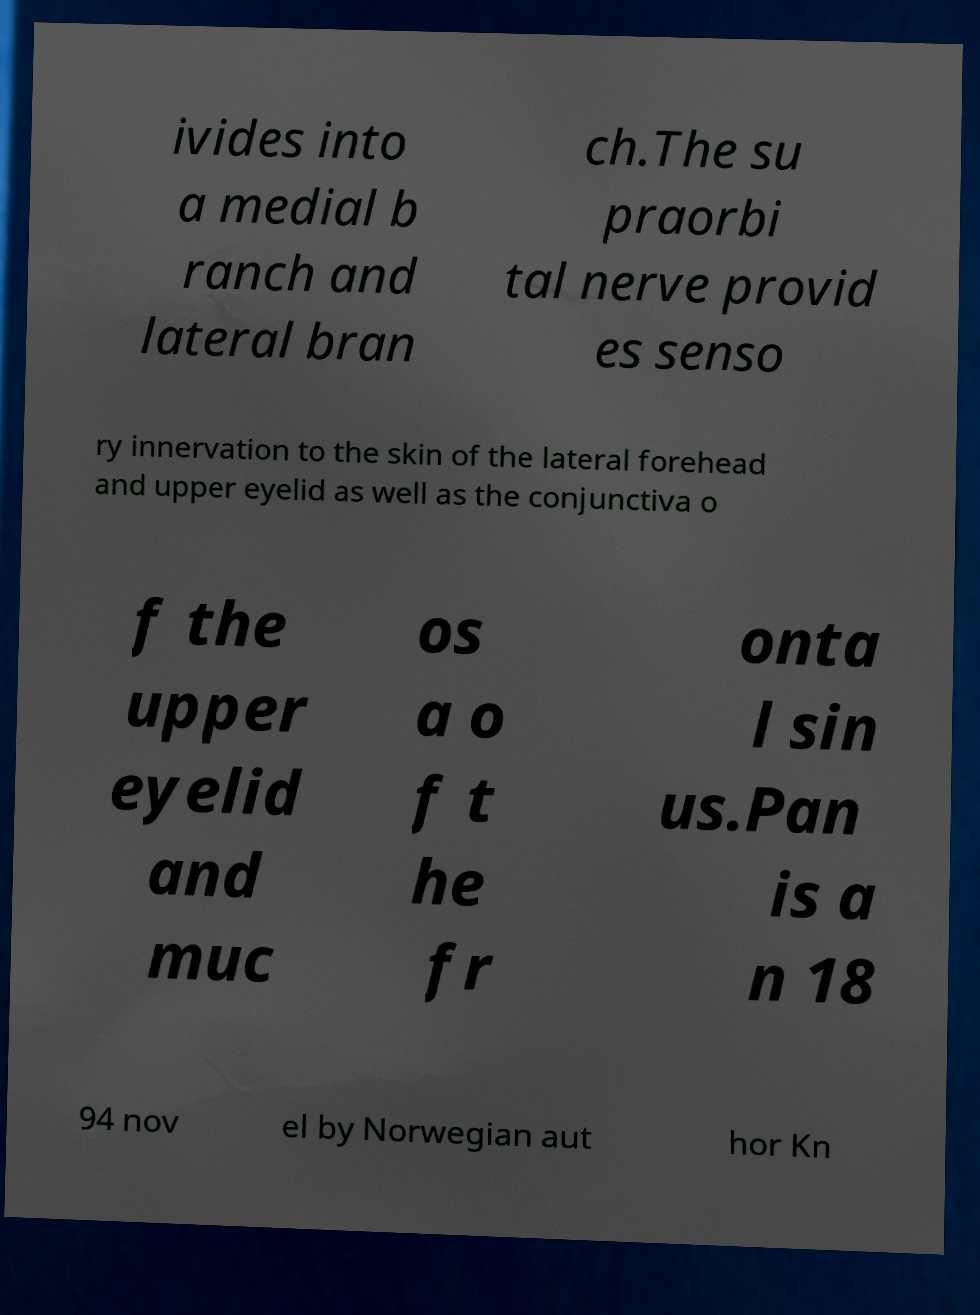Can you read and provide the text displayed in the image?This photo seems to have some interesting text. Can you extract and type it out for me? ivides into a medial b ranch and lateral bran ch.The su praorbi tal nerve provid es senso ry innervation to the skin of the lateral forehead and upper eyelid as well as the conjunctiva o f the upper eyelid and muc os a o f t he fr onta l sin us.Pan is a n 18 94 nov el by Norwegian aut hor Kn 